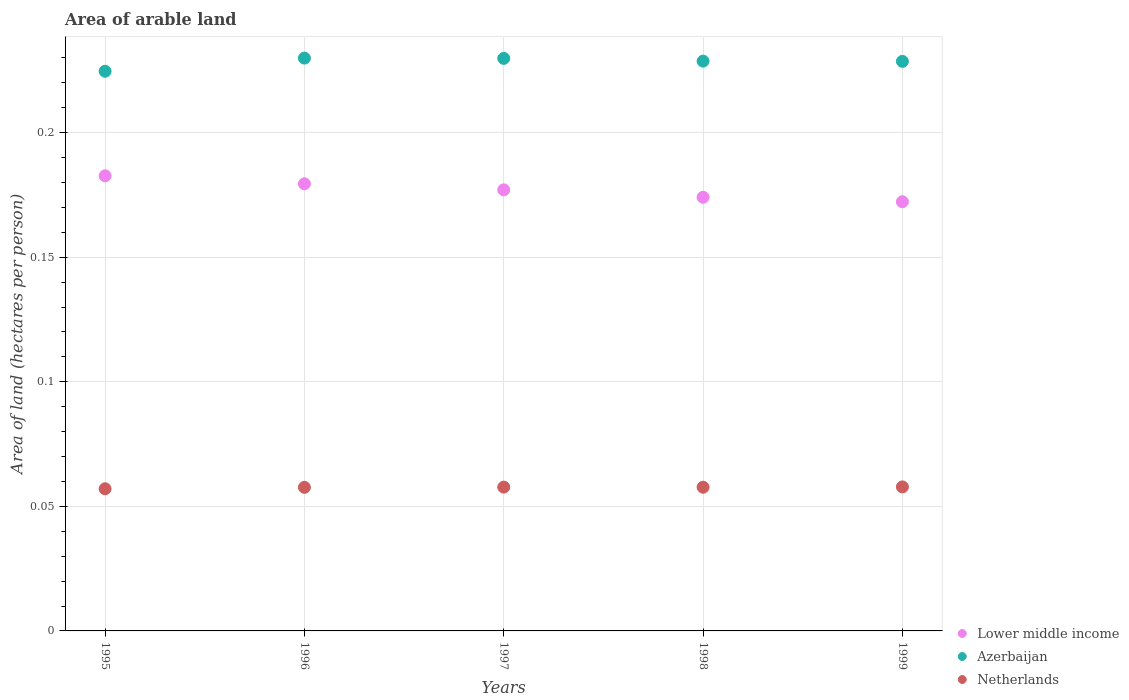What is the total arable land in Netherlands in 1995?
Give a very brief answer. 0.06. Across all years, what is the maximum total arable land in Azerbaijan?
Offer a terse response. 0.23. Across all years, what is the minimum total arable land in Lower middle income?
Give a very brief answer. 0.17. What is the total total arable land in Azerbaijan in the graph?
Keep it short and to the point. 1.14. What is the difference between the total arable land in Azerbaijan in 1997 and that in 1998?
Give a very brief answer. 0. What is the difference between the total arable land in Lower middle income in 1998 and the total arable land in Azerbaijan in 1997?
Provide a short and direct response. -0.06. What is the average total arable land in Azerbaijan per year?
Your answer should be very brief. 0.23. In the year 1995, what is the difference between the total arable land in Netherlands and total arable land in Lower middle income?
Your answer should be very brief. -0.13. In how many years, is the total arable land in Azerbaijan greater than 0.02 hectares per person?
Provide a succinct answer. 5. What is the ratio of the total arable land in Netherlands in 1996 to that in 1998?
Provide a succinct answer. 1. What is the difference between the highest and the second highest total arable land in Lower middle income?
Your answer should be compact. 0. What is the difference between the highest and the lowest total arable land in Azerbaijan?
Provide a short and direct response. 0.01. In how many years, is the total arable land in Netherlands greater than the average total arable land in Netherlands taken over all years?
Your answer should be compact. 4. Is the total arable land in Azerbaijan strictly less than the total arable land in Lower middle income over the years?
Give a very brief answer. No. How many years are there in the graph?
Your answer should be compact. 5. Are the values on the major ticks of Y-axis written in scientific E-notation?
Offer a terse response. No. Does the graph contain any zero values?
Your response must be concise. No. Does the graph contain grids?
Offer a terse response. Yes. How many legend labels are there?
Keep it short and to the point. 3. How are the legend labels stacked?
Offer a very short reply. Vertical. What is the title of the graph?
Your answer should be very brief. Area of arable land. Does "Slovenia" appear as one of the legend labels in the graph?
Your response must be concise. No. What is the label or title of the Y-axis?
Offer a terse response. Area of land (hectares per person). What is the Area of land (hectares per person) in Lower middle income in 1995?
Offer a terse response. 0.18. What is the Area of land (hectares per person) of Azerbaijan in 1995?
Provide a succinct answer. 0.22. What is the Area of land (hectares per person) of Netherlands in 1995?
Keep it short and to the point. 0.06. What is the Area of land (hectares per person) in Lower middle income in 1996?
Make the answer very short. 0.18. What is the Area of land (hectares per person) of Azerbaijan in 1996?
Offer a terse response. 0.23. What is the Area of land (hectares per person) of Netherlands in 1996?
Offer a very short reply. 0.06. What is the Area of land (hectares per person) in Lower middle income in 1997?
Keep it short and to the point. 0.18. What is the Area of land (hectares per person) of Azerbaijan in 1997?
Your response must be concise. 0.23. What is the Area of land (hectares per person) in Netherlands in 1997?
Offer a terse response. 0.06. What is the Area of land (hectares per person) of Lower middle income in 1998?
Keep it short and to the point. 0.17. What is the Area of land (hectares per person) of Azerbaijan in 1998?
Your response must be concise. 0.23. What is the Area of land (hectares per person) in Netherlands in 1998?
Make the answer very short. 0.06. What is the Area of land (hectares per person) in Lower middle income in 1999?
Make the answer very short. 0.17. What is the Area of land (hectares per person) in Azerbaijan in 1999?
Your answer should be very brief. 0.23. What is the Area of land (hectares per person) of Netherlands in 1999?
Your answer should be compact. 0.06. Across all years, what is the maximum Area of land (hectares per person) in Lower middle income?
Your response must be concise. 0.18. Across all years, what is the maximum Area of land (hectares per person) of Azerbaijan?
Offer a very short reply. 0.23. Across all years, what is the maximum Area of land (hectares per person) in Netherlands?
Give a very brief answer. 0.06. Across all years, what is the minimum Area of land (hectares per person) of Lower middle income?
Keep it short and to the point. 0.17. Across all years, what is the minimum Area of land (hectares per person) of Azerbaijan?
Make the answer very short. 0.22. Across all years, what is the minimum Area of land (hectares per person) in Netherlands?
Your answer should be very brief. 0.06. What is the total Area of land (hectares per person) in Lower middle income in the graph?
Your response must be concise. 0.89. What is the total Area of land (hectares per person) in Azerbaijan in the graph?
Make the answer very short. 1.14. What is the total Area of land (hectares per person) in Netherlands in the graph?
Your response must be concise. 0.29. What is the difference between the Area of land (hectares per person) in Lower middle income in 1995 and that in 1996?
Offer a terse response. 0. What is the difference between the Area of land (hectares per person) in Azerbaijan in 1995 and that in 1996?
Make the answer very short. -0.01. What is the difference between the Area of land (hectares per person) in Netherlands in 1995 and that in 1996?
Your answer should be very brief. -0. What is the difference between the Area of land (hectares per person) of Lower middle income in 1995 and that in 1997?
Provide a succinct answer. 0.01. What is the difference between the Area of land (hectares per person) of Azerbaijan in 1995 and that in 1997?
Your answer should be very brief. -0.01. What is the difference between the Area of land (hectares per person) in Netherlands in 1995 and that in 1997?
Offer a terse response. -0. What is the difference between the Area of land (hectares per person) in Lower middle income in 1995 and that in 1998?
Give a very brief answer. 0.01. What is the difference between the Area of land (hectares per person) of Azerbaijan in 1995 and that in 1998?
Ensure brevity in your answer.  -0. What is the difference between the Area of land (hectares per person) in Netherlands in 1995 and that in 1998?
Keep it short and to the point. -0. What is the difference between the Area of land (hectares per person) of Lower middle income in 1995 and that in 1999?
Ensure brevity in your answer.  0.01. What is the difference between the Area of land (hectares per person) of Azerbaijan in 1995 and that in 1999?
Give a very brief answer. -0. What is the difference between the Area of land (hectares per person) of Netherlands in 1995 and that in 1999?
Offer a very short reply. -0. What is the difference between the Area of land (hectares per person) in Lower middle income in 1996 and that in 1997?
Provide a short and direct response. 0. What is the difference between the Area of land (hectares per person) in Netherlands in 1996 and that in 1997?
Your response must be concise. -0. What is the difference between the Area of land (hectares per person) in Lower middle income in 1996 and that in 1998?
Your answer should be compact. 0.01. What is the difference between the Area of land (hectares per person) of Azerbaijan in 1996 and that in 1998?
Provide a short and direct response. 0. What is the difference between the Area of land (hectares per person) in Netherlands in 1996 and that in 1998?
Your response must be concise. -0. What is the difference between the Area of land (hectares per person) of Lower middle income in 1996 and that in 1999?
Make the answer very short. 0.01. What is the difference between the Area of land (hectares per person) of Azerbaijan in 1996 and that in 1999?
Provide a short and direct response. 0. What is the difference between the Area of land (hectares per person) in Netherlands in 1996 and that in 1999?
Make the answer very short. -0. What is the difference between the Area of land (hectares per person) of Lower middle income in 1997 and that in 1998?
Your response must be concise. 0. What is the difference between the Area of land (hectares per person) of Azerbaijan in 1997 and that in 1998?
Your response must be concise. 0. What is the difference between the Area of land (hectares per person) in Netherlands in 1997 and that in 1998?
Provide a short and direct response. 0. What is the difference between the Area of land (hectares per person) of Lower middle income in 1997 and that in 1999?
Offer a very short reply. 0. What is the difference between the Area of land (hectares per person) of Azerbaijan in 1997 and that in 1999?
Keep it short and to the point. 0. What is the difference between the Area of land (hectares per person) of Netherlands in 1997 and that in 1999?
Your answer should be very brief. -0. What is the difference between the Area of land (hectares per person) of Lower middle income in 1998 and that in 1999?
Your answer should be very brief. 0. What is the difference between the Area of land (hectares per person) of Netherlands in 1998 and that in 1999?
Give a very brief answer. -0. What is the difference between the Area of land (hectares per person) in Lower middle income in 1995 and the Area of land (hectares per person) in Azerbaijan in 1996?
Ensure brevity in your answer.  -0.05. What is the difference between the Area of land (hectares per person) in Lower middle income in 1995 and the Area of land (hectares per person) in Netherlands in 1996?
Provide a succinct answer. 0.13. What is the difference between the Area of land (hectares per person) of Azerbaijan in 1995 and the Area of land (hectares per person) of Netherlands in 1996?
Provide a short and direct response. 0.17. What is the difference between the Area of land (hectares per person) of Lower middle income in 1995 and the Area of land (hectares per person) of Azerbaijan in 1997?
Provide a succinct answer. -0.05. What is the difference between the Area of land (hectares per person) in Azerbaijan in 1995 and the Area of land (hectares per person) in Netherlands in 1997?
Make the answer very short. 0.17. What is the difference between the Area of land (hectares per person) of Lower middle income in 1995 and the Area of land (hectares per person) of Azerbaijan in 1998?
Make the answer very short. -0.05. What is the difference between the Area of land (hectares per person) in Lower middle income in 1995 and the Area of land (hectares per person) in Netherlands in 1998?
Offer a very short reply. 0.12. What is the difference between the Area of land (hectares per person) in Azerbaijan in 1995 and the Area of land (hectares per person) in Netherlands in 1998?
Provide a short and direct response. 0.17. What is the difference between the Area of land (hectares per person) in Lower middle income in 1995 and the Area of land (hectares per person) in Azerbaijan in 1999?
Keep it short and to the point. -0.05. What is the difference between the Area of land (hectares per person) of Lower middle income in 1995 and the Area of land (hectares per person) of Netherlands in 1999?
Make the answer very short. 0.12. What is the difference between the Area of land (hectares per person) of Azerbaijan in 1995 and the Area of land (hectares per person) of Netherlands in 1999?
Your answer should be compact. 0.17. What is the difference between the Area of land (hectares per person) of Lower middle income in 1996 and the Area of land (hectares per person) of Azerbaijan in 1997?
Your response must be concise. -0.05. What is the difference between the Area of land (hectares per person) of Lower middle income in 1996 and the Area of land (hectares per person) of Netherlands in 1997?
Your answer should be very brief. 0.12. What is the difference between the Area of land (hectares per person) in Azerbaijan in 1996 and the Area of land (hectares per person) in Netherlands in 1997?
Keep it short and to the point. 0.17. What is the difference between the Area of land (hectares per person) in Lower middle income in 1996 and the Area of land (hectares per person) in Azerbaijan in 1998?
Give a very brief answer. -0.05. What is the difference between the Area of land (hectares per person) of Lower middle income in 1996 and the Area of land (hectares per person) of Netherlands in 1998?
Your answer should be compact. 0.12. What is the difference between the Area of land (hectares per person) of Azerbaijan in 1996 and the Area of land (hectares per person) of Netherlands in 1998?
Offer a terse response. 0.17. What is the difference between the Area of land (hectares per person) in Lower middle income in 1996 and the Area of land (hectares per person) in Azerbaijan in 1999?
Your response must be concise. -0.05. What is the difference between the Area of land (hectares per person) in Lower middle income in 1996 and the Area of land (hectares per person) in Netherlands in 1999?
Ensure brevity in your answer.  0.12. What is the difference between the Area of land (hectares per person) of Azerbaijan in 1996 and the Area of land (hectares per person) of Netherlands in 1999?
Your answer should be very brief. 0.17. What is the difference between the Area of land (hectares per person) in Lower middle income in 1997 and the Area of land (hectares per person) in Azerbaijan in 1998?
Provide a short and direct response. -0.05. What is the difference between the Area of land (hectares per person) of Lower middle income in 1997 and the Area of land (hectares per person) of Netherlands in 1998?
Provide a short and direct response. 0.12. What is the difference between the Area of land (hectares per person) in Azerbaijan in 1997 and the Area of land (hectares per person) in Netherlands in 1998?
Your response must be concise. 0.17. What is the difference between the Area of land (hectares per person) in Lower middle income in 1997 and the Area of land (hectares per person) in Azerbaijan in 1999?
Make the answer very short. -0.05. What is the difference between the Area of land (hectares per person) of Lower middle income in 1997 and the Area of land (hectares per person) of Netherlands in 1999?
Make the answer very short. 0.12. What is the difference between the Area of land (hectares per person) in Azerbaijan in 1997 and the Area of land (hectares per person) in Netherlands in 1999?
Make the answer very short. 0.17. What is the difference between the Area of land (hectares per person) in Lower middle income in 1998 and the Area of land (hectares per person) in Azerbaijan in 1999?
Your answer should be compact. -0.05. What is the difference between the Area of land (hectares per person) in Lower middle income in 1998 and the Area of land (hectares per person) in Netherlands in 1999?
Offer a terse response. 0.12. What is the difference between the Area of land (hectares per person) in Azerbaijan in 1998 and the Area of land (hectares per person) in Netherlands in 1999?
Offer a terse response. 0.17. What is the average Area of land (hectares per person) in Lower middle income per year?
Offer a very short reply. 0.18. What is the average Area of land (hectares per person) in Azerbaijan per year?
Provide a short and direct response. 0.23. What is the average Area of land (hectares per person) of Netherlands per year?
Give a very brief answer. 0.06. In the year 1995, what is the difference between the Area of land (hectares per person) in Lower middle income and Area of land (hectares per person) in Azerbaijan?
Make the answer very short. -0.04. In the year 1995, what is the difference between the Area of land (hectares per person) of Lower middle income and Area of land (hectares per person) of Netherlands?
Offer a very short reply. 0.13. In the year 1995, what is the difference between the Area of land (hectares per person) in Azerbaijan and Area of land (hectares per person) in Netherlands?
Make the answer very short. 0.17. In the year 1996, what is the difference between the Area of land (hectares per person) of Lower middle income and Area of land (hectares per person) of Azerbaijan?
Provide a succinct answer. -0.05. In the year 1996, what is the difference between the Area of land (hectares per person) of Lower middle income and Area of land (hectares per person) of Netherlands?
Your response must be concise. 0.12. In the year 1996, what is the difference between the Area of land (hectares per person) of Azerbaijan and Area of land (hectares per person) of Netherlands?
Ensure brevity in your answer.  0.17. In the year 1997, what is the difference between the Area of land (hectares per person) of Lower middle income and Area of land (hectares per person) of Azerbaijan?
Your answer should be compact. -0.05. In the year 1997, what is the difference between the Area of land (hectares per person) in Lower middle income and Area of land (hectares per person) in Netherlands?
Provide a short and direct response. 0.12. In the year 1997, what is the difference between the Area of land (hectares per person) in Azerbaijan and Area of land (hectares per person) in Netherlands?
Offer a very short reply. 0.17. In the year 1998, what is the difference between the Area of land (hectares per person) in Lower middle income and Area of land (hectares per person) in Azerbaijan?
Provide a succinct answer. -0.05. In the year 1998, what is the difference between the Area of land (hectares per person) in Lower middle income and Area of land (hectares per person) in Netherlands?
Keep it short and to the point. 0.12. In the year 1998, what is the difference between the Area of land (hectares per person) of Azerbaijan and Area of land (hectares per person) of Netherlands?
Keep it short and to the point. 0.17. In the year 1999, what is the difference between the Area of land (hectares per person) in Lower middle income and Area of land (hectares per person) in Azerbaijan?
Your answer should be compact. -0.06. In the year 1999, what is the difference between the Area of land (hectares per person) in Lower middle income and Area of land (hectares per person) in Netherlands?
Your response must be concise. 0.11. In the year 1999, what is the difference between the Area of land (hectares per person) in Azerbaijan and Area of land (hectares per person) in Netherlands?
Your response must be concise. 0.17. What is the ratio of the Area of land (hectares per person) in Lower middle income in 1995 to that in 1996?
Give a very brief answer. 1.02. What is the ratio of the Area of land (hectares per person) in Lower middle income in 1995 to that in 1997?
Ensure brevity in your answer.  1.03. What is the ratio of the Area of land (hectares per person) of Azerbaijan in 1995 to that in 1997?
Ensure brevity in your answer.  0.98. What is the ratio of the Area of land (hectares per person) in Lower middle income in 1995 to that in 1998?
Your response must be concise. 1.05. What is the ratio of the Area of land (hectares per person) in Azerbaijan in 1995 to that in 1998?
Provide a succinct answer. 0.98. What is the ratio of the Area of land (hectares per person) in Netherlands in 1995 to that in 1998?
Give a very brief answer. 0.99. What is the ratio of the Area of land (hectares per person) of Lower middle income in 1995 to that in 1999?
Make the answer very short. 1.06. What is the ratio of the Area of land (hectares per person) in Azerbaijan in 1995 to that in 1999?
Your answer should be compact. 0.98. What is the ratio of the Area of land (hectares per person) of Netherlands in 1995 to that in 1999?
Give a very brief answer. 0.99. What is the ratio of the Area of land (hectares per person) in Lower middle income in 1996 to that in 1997?
Your answer should be very brief. 1.01. What is the ratio of the Area of land (hectares per person) in Netherlands in 1996 to that in 1997?
Give a very brief answer. 1. What is the ratio of the Area of land (hectares per person) in Lower middle income in 1996 to that in 1998?
Offer a terse response. 1.03. What is the ratio of the Area of land (hectares per person) of Netherlands in 1996 to that in 1998?
Provide a succinct answer. 1. What is the ratio of the Area of land (hectares per person) of Lower middle income in 1996 to that in 1999?
Offer a very short reply. 1.04. What is the ratio of the Area of land (hectares per person) of Azerbaijan in 1996 to that in 1999?
Make the answer very short. 1.01. What is the ratio of the Area of land (hectares per person) in Netherlands in 1996 to that in 1999?
Provide a short and direct response. 1. What is the ratio of the Area of land (hectares per person) in Lower middle income in 1997 to that in 1998?
Offer a terse response. 1.02. What is the ratio of the Area of land (hectares per person) of Lower middle income in 1997 to that in 1999?
Provide a short and direct response. 1.03. What is the ratio of the Area of land (hectares per person) of Azerbaijan in 1997 to that in 1999?
Your response must be concise. 1.01. What is the ratio of the Area of land (hectares per person) in Lower middle income in 1998 to that in 1999?
Your answer should be very brief. 1.01. What is the ratio of the Area of land (hectares per person) in Azerbaijan in 1998 to that in 1999?
Offer a terse response. 1. What is the difference between the highest and the second highest Area of land (hectares per person) in Lower middle income?
Keep it short and to the point. 0. What is the difference between the highest and the second highest Area of land (hectares per person) in Azerbaijan?
Your response must be concise. 0. What is the difference between the highest and the lowest Area of land (hectares per person) of Lower middle income?
Provide a succinct answer. 0.01. What is the difference between the highest and the lowest Area of land (hectares per person) of Azerbaijan?
Your response must be concise. 0.01. What is the difference between the highest and the lowest Area of land (hectares per person) in Netherlands?
Offer a terse response. 0. 